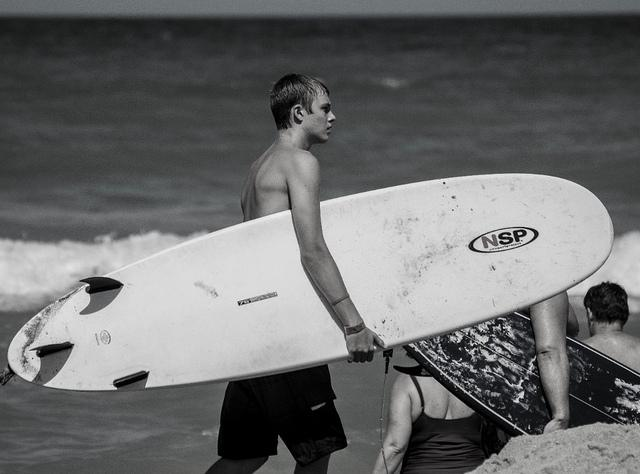What are the black triangular pieces on the board called?

Choices:
A) wings
B) hooks
C) traps
D) fins fins 